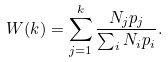<formula> <loc_0><loc_0><loc_500><loc_500>W ( k ) = \sum _ { j = 1 } ^ { k } \frac { N _ { j } p _ { j } } { \sum _ { i } N _ { i } p _ { i } } .</formula> 